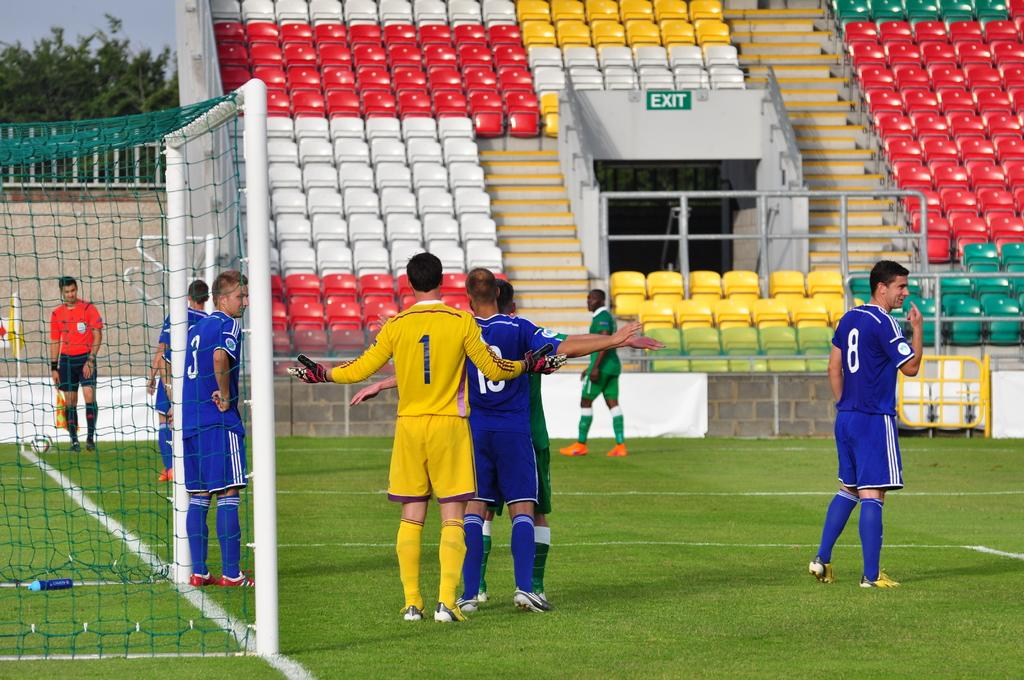Provide a one-sentence caption for the provided image. Numbers 1 and 18 fight for position before a corner kick. 